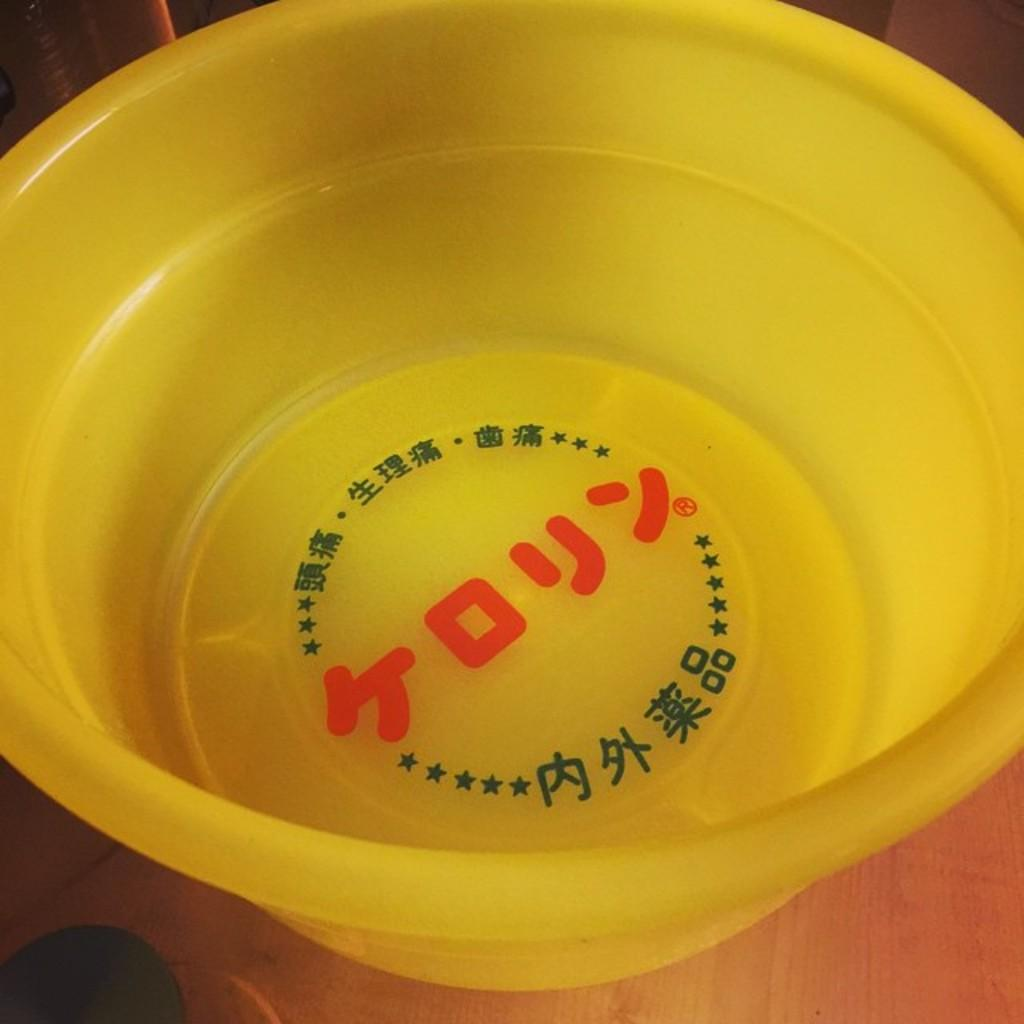What is the color of the tub in the image? The tub in the image is yellow. Are there any markings or symbols on the tub? Yes, the tub has symbols on it. What can be seen near the tub in the image? There are objects visible at the side of the tub. What type of lipstick is the secretary wearing in the image? There is no secretary or lipstick present in the image; it only features a yellow tub with symbols on it and objects nearby. 